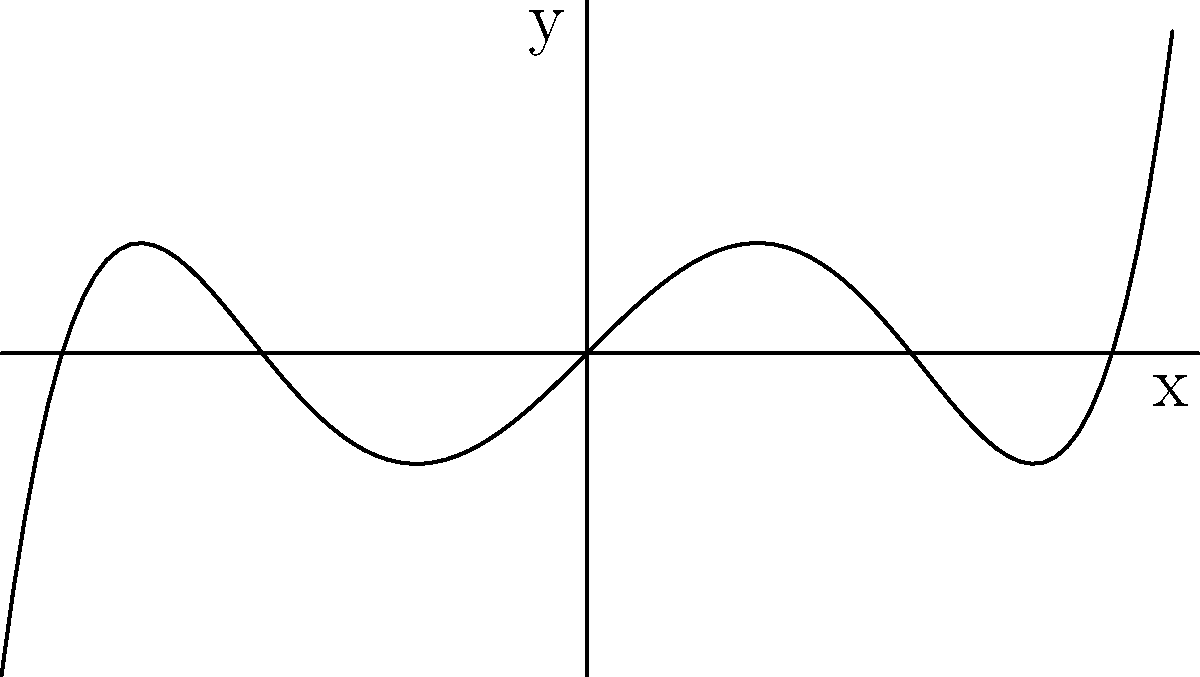As you prepare for your engineering studies in France, you encounter a question about polynomial functions. Given a polynomial of degree 5, what is the maximum number of turning points (local maxima and minima) that its graph can have? How does this relate to the polynomial's degree? To determine the maximum number of turning points in a polynomial graph, we can follow these steps:

1. Recall that the degree of a polynomial is the highest power of the variable in the polynomial.

2. The relationship between the degree of a polynomial and the maximum number of turning points is given by the formula:

   Maximum number of turning points = (Degree of polynomial) - 1

3. In this case, we have a polynomial of degree 5.

4. Apply the formula:
   Maximum number of turning points = 5 - 1 = 4

5. This means that a polynomial of degree 5 can have at most 4 turning points.

6. The reason for this relationship is that the derivative of a polynomial of degree $n$ is a polynomial of degree $n-1$. The turning points occur where the derivative is zero, and a polynomial of degree $n-1$ can have at most $n-1$ roots.

7. It's important to note that this is the maximum number of turning points. A polynomial of degree 5 could have fewer than 4 turning points, but it cannot have more than 4.

This concept is crucial in engineering applications, especially in modeling complex systems and analyzing wave functions in quantum mechanics, which you might encounter in your studies in France.
Answer: 4 turning points 